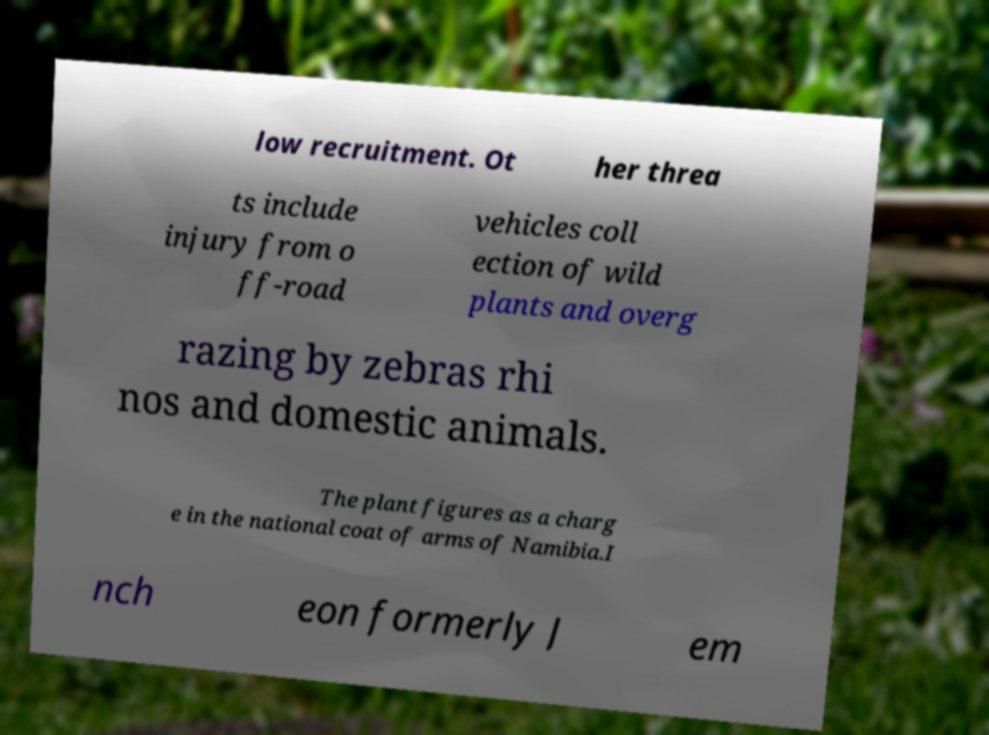I need the written content from this picture converted into text. Can you do that? low recruitment. Ot her threa ts include injury from o ff-road vehicles coll ection of wild plants and overg razing by zebras rhi nos and domestic animals. The plant figures as a charg e in the national coat of arms of Namibia.I nch eon formerly J em 